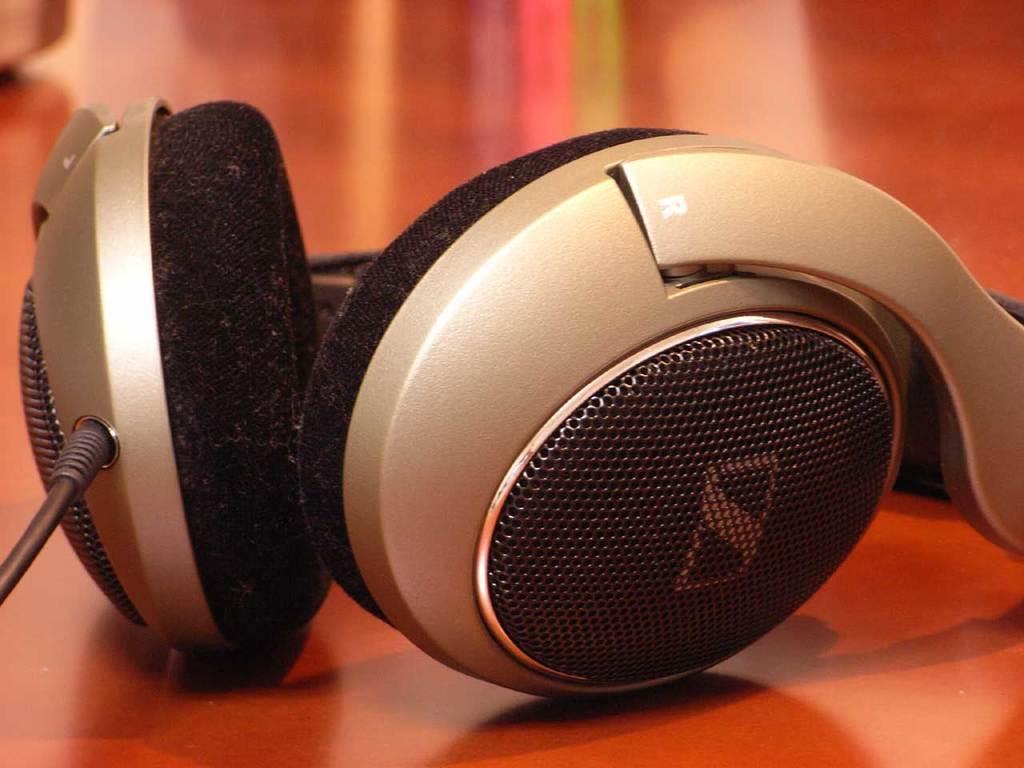How would you summarize this image in a sentence or two? In this image we can see a headset and a wire. 